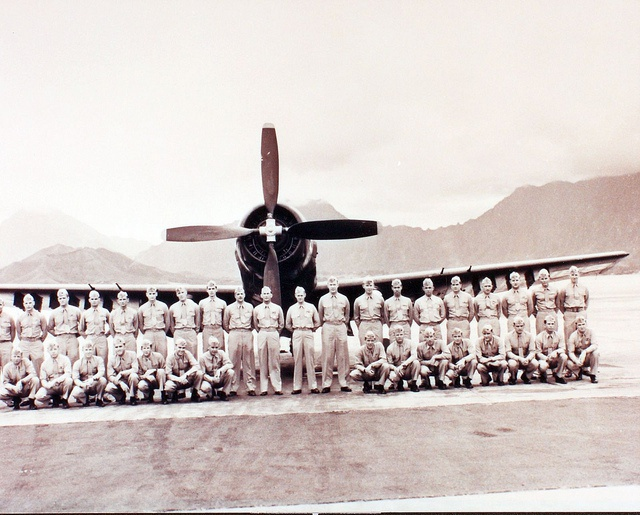Describe the objects in this image and their specific colors. I can see people in white, lightgray, darkgray, and black tones, airplane in white, black, lightgray, brown, and gray tones, tie in white, lightgray, darkgray, and gray tones, people in white, lightgray, darkgray, and gray tones, and people in white, lightgray, darkgray, and gray tones in this image. 